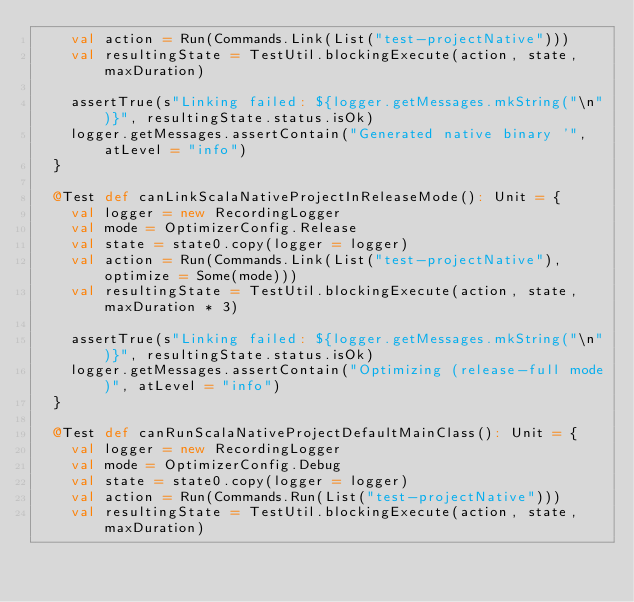Convert code to text. <code><loc_0><loc_0><loc_500><loc_500><_Scala_>    val action = Run(Commands.Link(List("test-projectNative")))
    val resultingState = TestUtil.blockingExecute(action, state, maxDuration)

    assertTrue(s"Linking failed: ${logger.getMessages.mkString("\n")}", resultingState.status.isOk)
    logger.getMessages.assertContain("Generated native binary '", atLevel = "info")
  }

  @Test def canLinkScalaNativeProjectInReleaseMode(): Unit = {
    val logger = new RecordingLogger
    val mode = OptimizerConfig.Release
    val state = state0.copy(logger = logger)
    val action = Run(Commands.Link(List("test-projectNative"), optimize = Some(mode)))
    val resultingState = TestUtil.blockingExecute(action, state, maxDuration * 3)

    assertTrue(s"Linking failed: ${logger.getMessages.mkString("\n")}", resultingState.status.isOk)
    logger.getMessages.assertContain("Optimizing (release-full mode)", atLevel = "info")
  }

  @Test def canRunScalaNativeProjectDefaultMainClass(): Unit = {
    val logger = new RecordingLogger
    val mode = OptimizerConfig.Debug
    val state = state0.copy(logger = logger)
    val action = Run(Commands.Run(List("test-projectNative")))
    val resultingState = TestUtil.blockingExecute(action, state, maxDuration)
</code> 